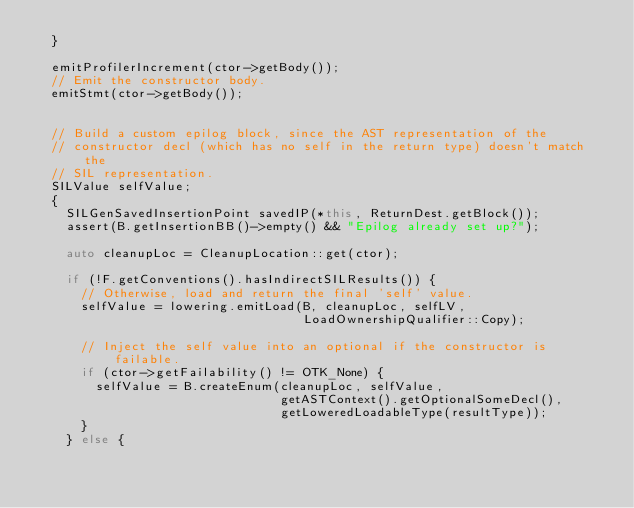<code> <loc_0><loc_0><loc_500><loc_500><_C++_>  }

  emitProfilerIncrement(ctor->getBody());
  // Emit the constructor body.
  emitStmt(ctor->getBody());

  
  // Build a custom epilog block, since the AST representation of the
  // constructor decl (which has no self in the return type) doesn't match the
  // SIL representation.
  SILValue selfValue;
  {
    SILGenSavedInsertionPoint savedIP(*this, ReturnDest.getBlock());
    assert(B.getInsertionBB()->empty() && "Epilog already set up?");
    
    auto cleanupLoc = CleanupLocation::get(ctor);

    if (!F.getConventions().hasIndirectSILResults()) {
      // Otherwise, load and return the final 'self' value.
      selfValue = lowering.emitLoad(B, cleanupLoc, selfLV,
                                    LoadOwnershipQualifier::Copy);

      // Inject the self value into an optional if the constructor is failable.
      if (ctor->getFailability() != OTK_None) {
        selfValue = B.createEnum(cleanupLoc, selfValue,
                                 getASTContext().getOptionalSomeDecl(),
                                 getLoweredLoadableType(resultType));
      }
    } else {</code> 